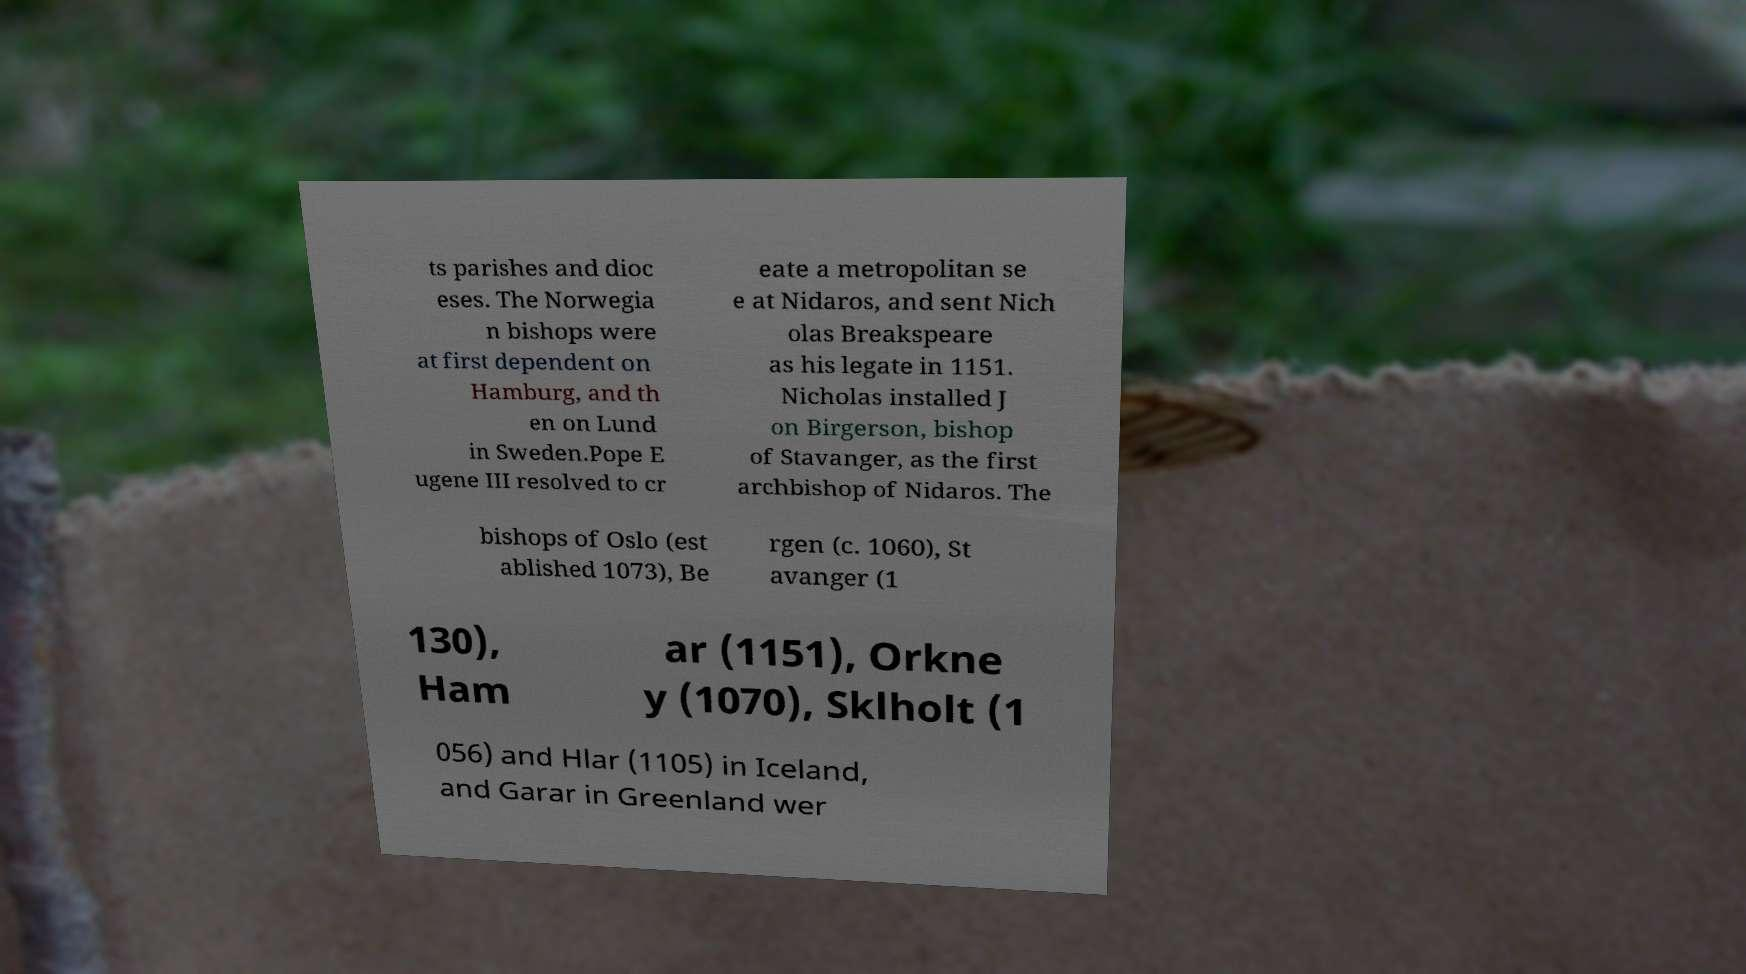There's text embedded in this image that I need extracted. Can you transcribe it verbatim? ts parishes and dioc eses. The Norwegia n bishops were at first dependent on Hamburg, and th en on Lund in Sweden.Pope E ugene III resolved to cr eate a metropolitan se e at Nidaros, and sent Nich olas Breakspeare as his legate in 1151. Nicholas installed J on Birgerson, bishop of Stavanger, as the first archbishop of Nidaros. The bishops of Oslo (est ablished 1073), Be rgen (c. 1060), St avanger (1 130), Ham ar (1151), Orkne y (1070), Sklholt (1 056) and Hlar (1105) in Iceland, and Garar in Greenland wer 